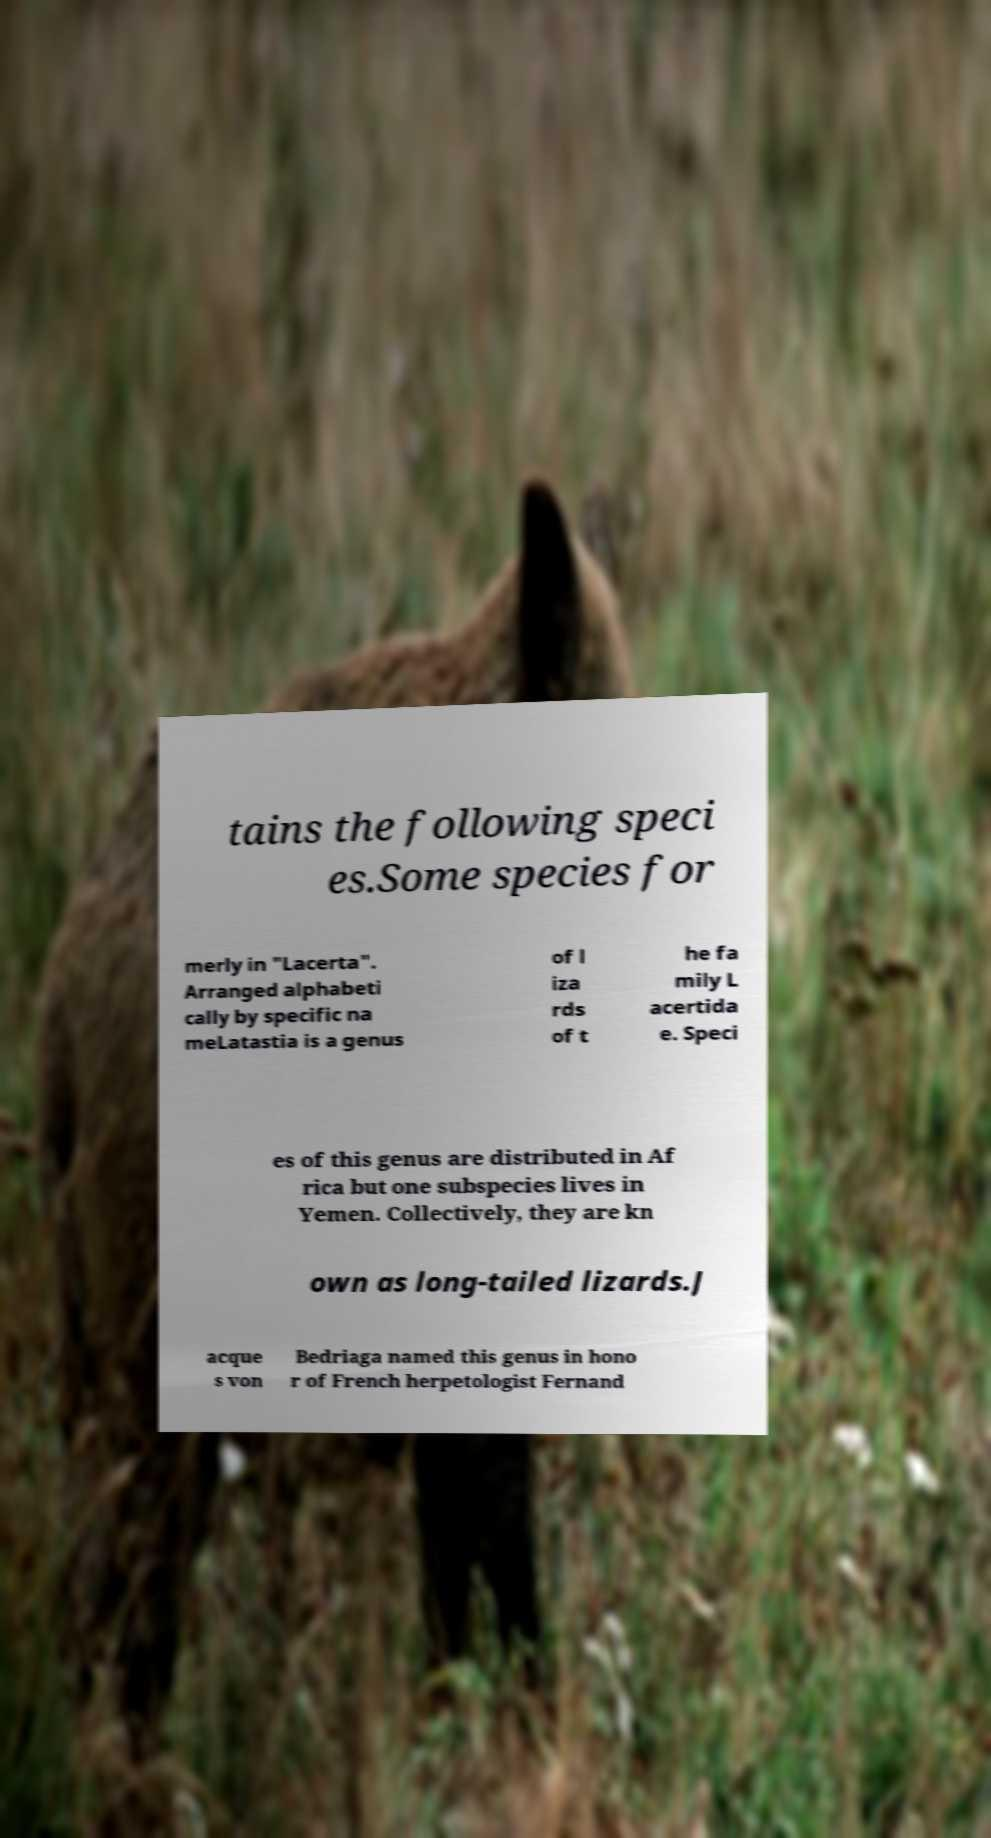Can you accurately transcribe the text from the provided image for me? tains the following speci es.Some species for merly in "Lacerta". Arranged alphabeti cally by specific na meLatastia is a genus of l iza rds of t he fa mily L acertida e. Speci es of this genus are distributed in Af rica but one subspecies lives in Yemen. Collectively, they are kn own as long-tailed lizards.J acque s von Bedriaga named this genus in hono r of French herpetologist Fernand 